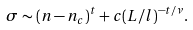Convert formula to latex. <formula><loc_0><loc_0><loc_500><loc_500>\sigma \sim ( n - n _ { c } ) ^ { t } + c ( L / l ) ^ { - t / \nu } .</formula> 